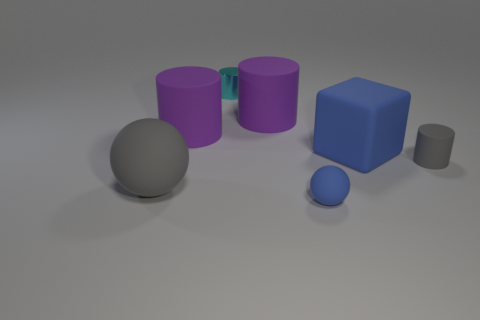Subtract all metal cylinders. How many cylinders are left? 3 Subtract all brown balls. How many purple cylinders are left? 2 Subtract 1 cylinders. How many cylinders are left? 3 Subtract all gray cylinders. How many cylinders are left? 3 Subtract all green cylinders. Subtract all red cubes. How many cylinders are left? 4 Add 2 blue blocks. How many objects exist? 9 Subtract all balls. How many objects are left? 5 Subtract all purple spheres. Subtract all cyan cylinders. How many objects are left? 6 Add 5 big blue objects. How many big blue objects are left? 6 Add 7 big gray cylinders. How many big gray cylinders exist? 7 